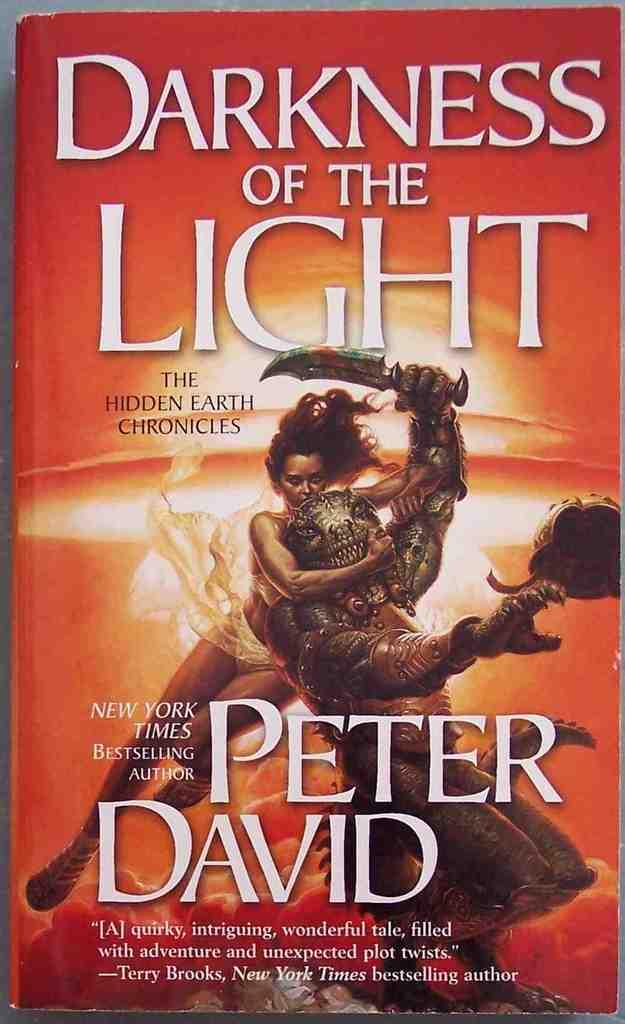What is present in the image that contains both text and an image? There is a poster in the image that contains text and an image. Can you describe the content of the poster? The poster contains text and an image, but the specific content cannot be determined from the provided facts. How many rings are visible on the hydrant in the image? There is no hydrant or rings present in the image. 